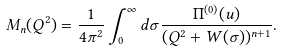<formula> <loc_0><loc_0><loc_500><loc_500>M _ { n } ( Q ^ { 2 } ) = \frac { 1 } { 4 \pi ^ { 2 } } \int _ { 0 } ^ { \infty } d \sigma \frac { \Pi ^ { ( 0 ) } ( u ) } { ( Q ^ { 2 } + W ( \sigma ) ) ^ { n + 1 } } .</formula> 